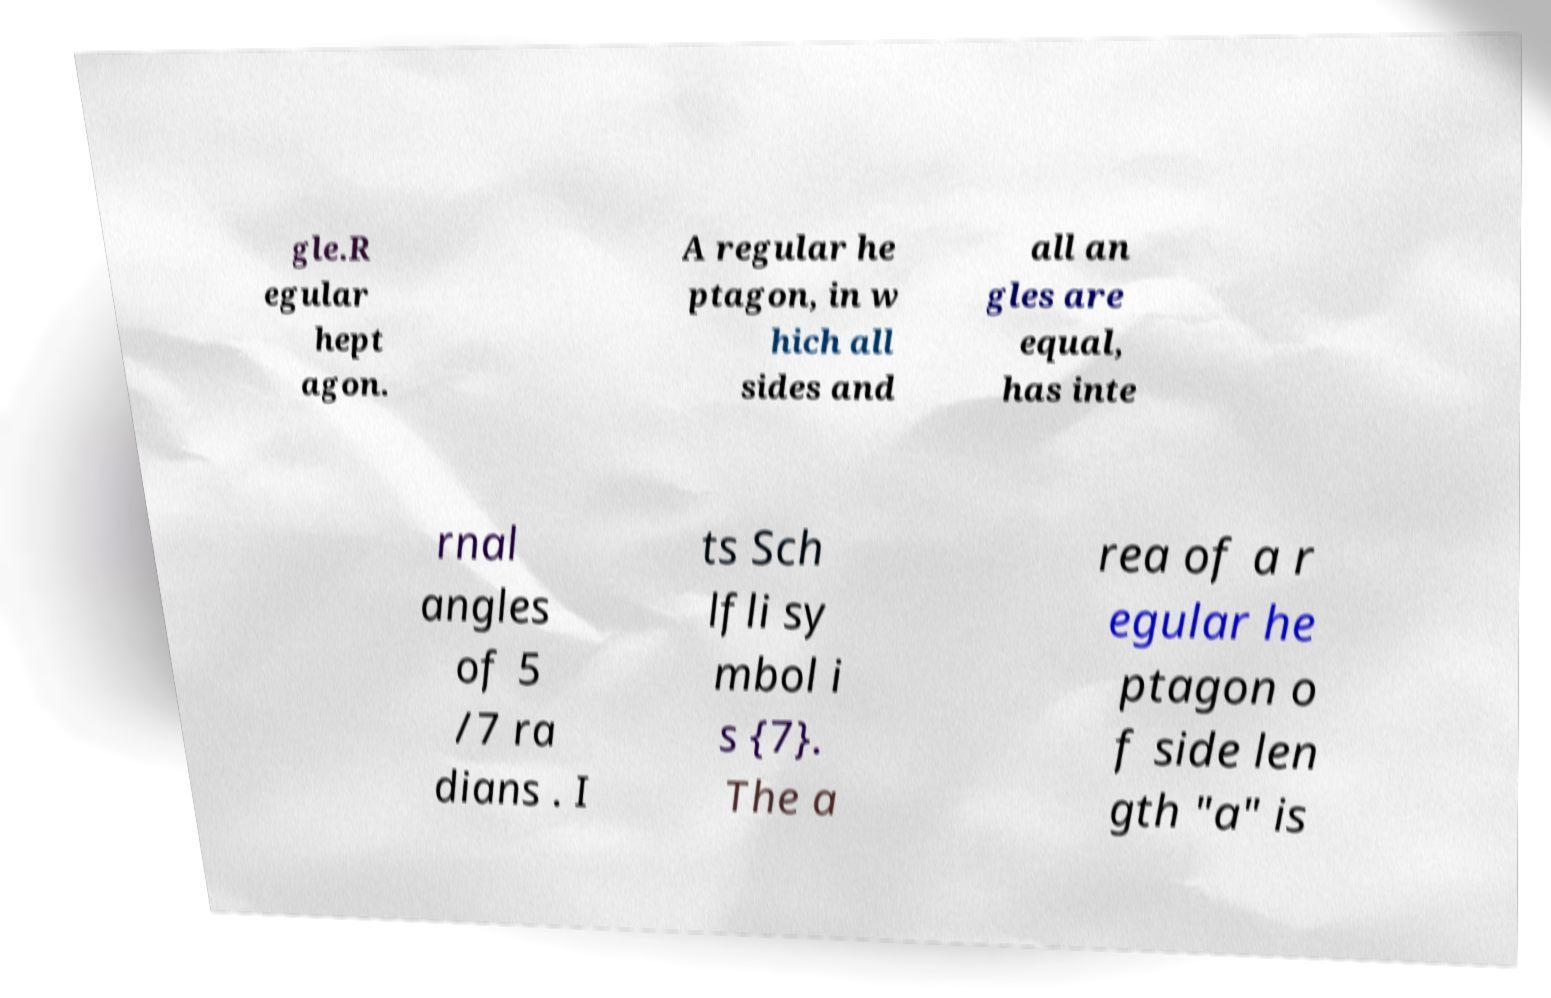For documentation purposes, I need the text within this image transcribed. Could you provide that? gle.R egular hept agon. A regular he ptagon, in w hich all sides and all an gles are equal, has inte rnal angles of 5 /7 ra dians . I ts Sch lfli sy mbol i s {7}. The a rea of a r egular he ptagon o f side len gth "a" is 